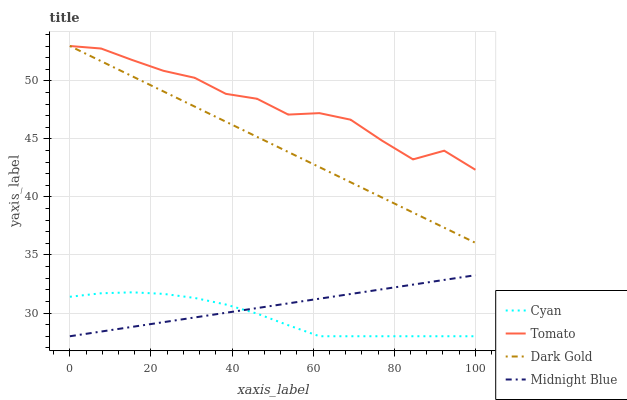Does Cyan have the minimum area under the curve?
Answer yes or no. Yes. Does Tomato have the maximum area under the curve?
Answer yes or no. Yes. Does Midnight Blue have the minimum area under the curve?
Answer yes or no. No. Does Midnight Blue have the maximum area under the curve?
Answer yes or no. No. Is Dark Gold the smoothest?
Answer yes or no. Yes. Is Tomato the roughest?
Answer yes or no. Yes. Is Cyan the smoothest?
Answer yes or no. No. Is Cyan the roughest?
Answer yes or no. No. Does Dark Gold have the lowest value?
Answer yes or no. No. Does Dark Gold have the highest value?
Answer yes or no. Yes. Does Midnight Blue have the highest value?
Answer yes or no. No. Is Cyan less than Dark Gold?
Answer yes or no. Yes. Is Dark Gold greater than Cyan?
Answer yes or no. Yes. Does Midnight Blue intersect Cyan?
Answer yes or no. Yes. Is Midnight Blue less than Cyan?
Answer yes or no. No. Is Midnight Blue greater than Cyan?
Answer yes or no. No. Does Cyan intersect Dark Gold?
Answer yes or no. No. 